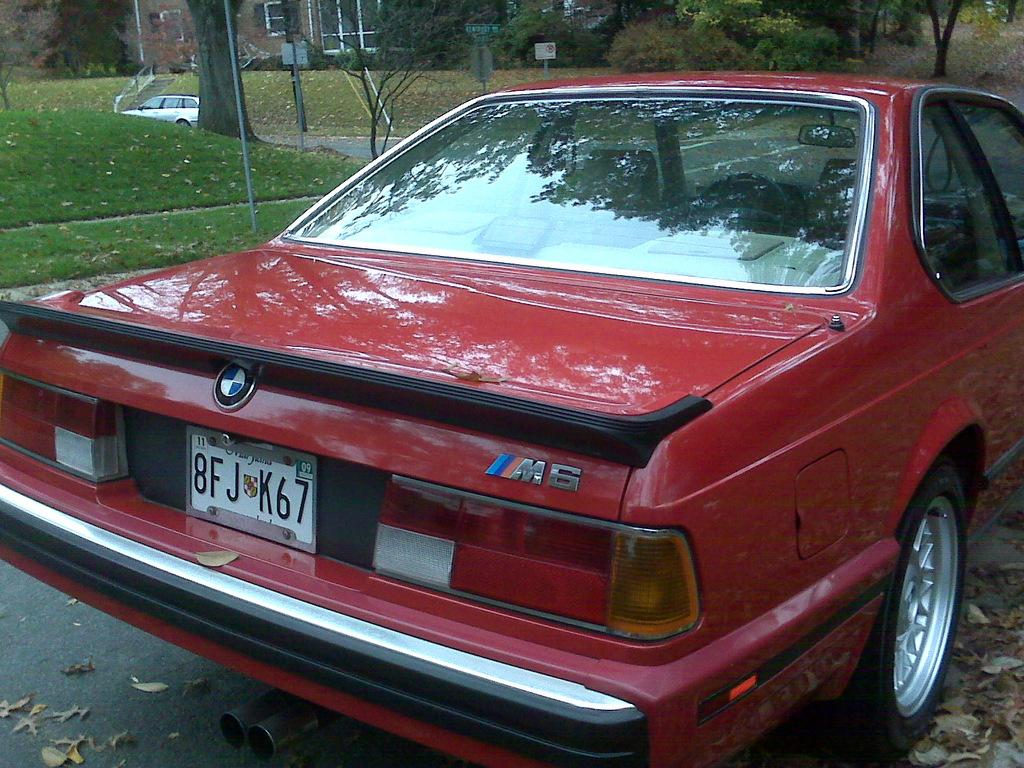What is on the road in the image? There is a car on the road in the image. What else can be seen in the background of the image? There is a vehicle, trees, poles, a building, grass, and windows in the background. How many vehicles are visible in the image? There are two vehicles visible in the image, one on the road and one in the background. What type of vegetation is present in the background? There are trees and grass in the background. What book is the car reading while driving in the image? There is no book present in the image, and the car is not shown reading anything. 